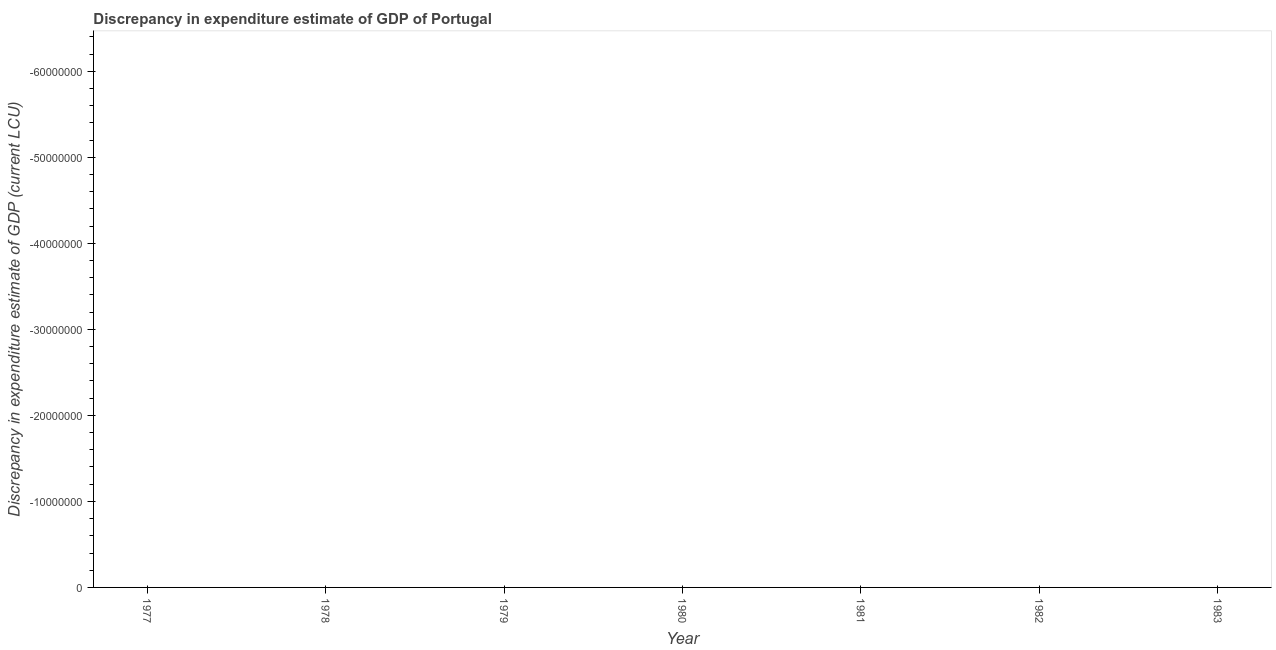Across all years, what is the minimum discrepancy in expenditure estimate of gdp?
Ensure brevity in your answer.  0. What is the median discrepancy in expenditure estimate of gdp?
Keep it short and to the point. 0. In how many years, is the discrepancy in expenditure estimate of gdp greater than the average discrepancy in expenditure estimate of gdp taken over all years?
Provide a short and direct response. 0. How many dotlines are there?
Offer a terse response. 0. How many years are there in the graph?
Keep it short and to the point. 7. Are the values on the major ticks of Y-axis written in scientific E-notation?
Provide a short and direct response. No. Does the graph contain any zero values?
Provide a short and direct response. Yes. What is the title of the graph?
Offer a terse response. Discrepancy in expenditure estimate of GDP of Portugal. What is the label or title of the Y-axis?
Your answer should be compact. Discrepancy in expenditure estimate of GDP (current LCU). What is the Discrepancy in expenditure estimate of GDP (current LCU) in 1977?
Your response must be concise. 0. What is the Discrepancy in expenditure estimate of GDP (current LCU) in 1978?
Your answer should be compact. 0. What is the Discrepancy in expenditure estimate of GDP (current LCU) in 1980?
Provide a succinct answer. 0. What is the Discrepancy in expenditure estimate of GDP (current LCU) in 1983?
Offer a terse response. 0. 